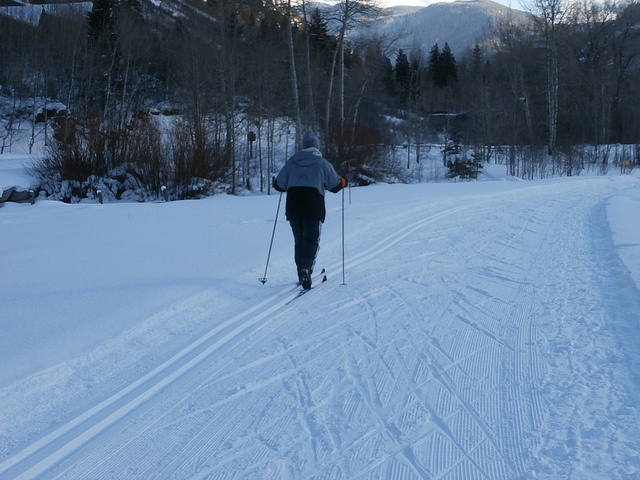Describe the objects in this image and their specific colors. I can see people in black, navy, darkblue, and darkgray tones and skis in black, gray, blue, and darkgray tones in this image. 